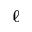Convert formula to latex. <formula><loc_0><loc_0><loc_500><loc_500>\ell</formula> 